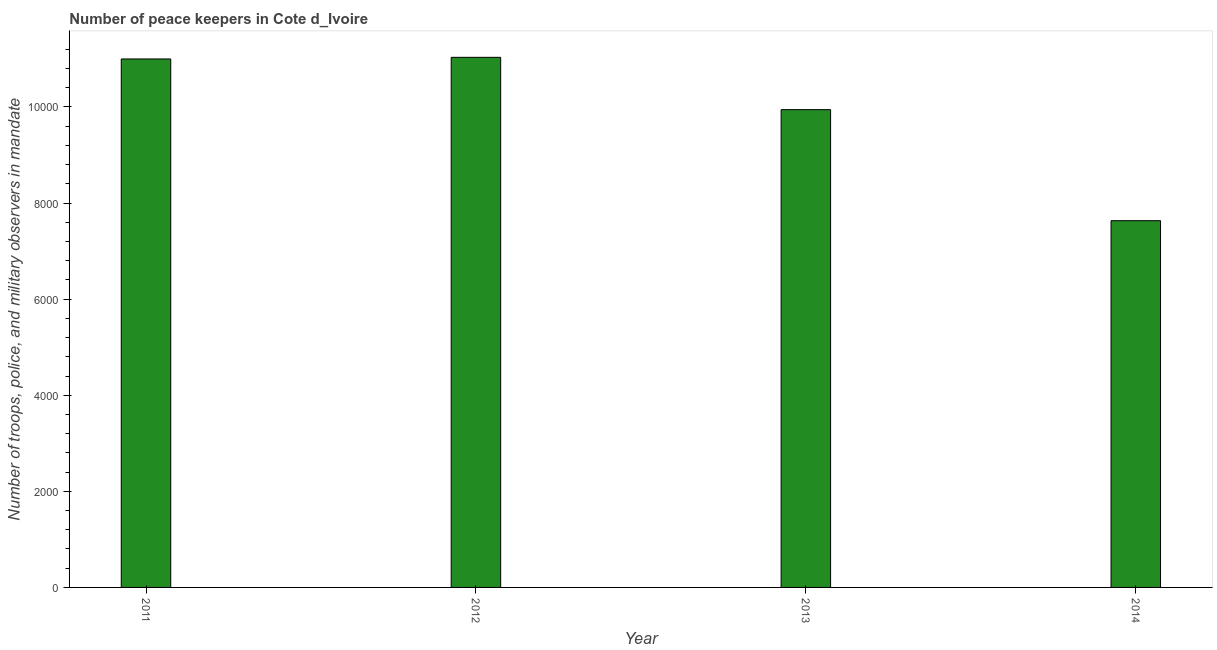Does the graph contain grids?
Provide a short and direct response. No. What is the title of the graph?
Provide a succinct answer. Number of peace keepers in Cote d_Ivoire. What is the label or title of the Y-axis?
Your answer should be very brief. Number of troops, police, and military observers in mandate. What is the number of peace keepers in 2014?
Offer a terse response. 7633. Across all years, what is the maximum number of peace keepers?
Give a very brief answer. 1.10e+04. Across all years, what is the minimum number of peace keepers?
Keep it short and to the point. 7633. In which year was the number of peace keepers minimum?
Make the answer very short. 2014. What is the sum of the number of peace keepers?
Give a very brief answer. 3.96e+04. What is the difference between the number of peace keepers in 2013 and 2014?
Provide a succinct answer. 2311. What is the average number of peace keepers per year?
Provide a succinct answer. 9902. What is the median number of peace keepers?
Keep it short and to the point. 1.05e+04. What is the ratio of the number of peace keepers in 2012 to that in 2013?
Offer a terse response. 1.11. Is the number of peace keepers in 2012 less than that in 2014?
Keep it short and to the point. No. What is the difference between the highest and the second highest number of peace keepers?
Offer a very short reply. 34. Is the sum of the number of peace keepers in 2013 and 2014 greater than the maximum number of peace keepers across all years?
Offer a terse response. Yes. What is the difference between the highest and the lowest number of peace keepers?
Your answer should be compact. 3400. In how many years, is the number of peace keepers greater than the average number of peace keepers taken over all years?
Offer a very short reply. 3. Are all the bars in the graph horizontal?
Make the answer very short. No. What is the difference between two consecutive major ticks on the Y-axis?
Make the answer very short. 2000. Are the values on the major ticks of Y-axis written in scientific E-notation?
Ensure brevity in your answer.  No. What is the Number of troops, police, and military observers in mandate in 2011?
Ensure brevity in your answer.  1.10e+04. What is the Number of troops, police, and military observers in mandate of 2012?
Your response must be concise. 1.10e+04. What is the Number of troops, police, and military observers in mandate of 2013?
Your response must be concise. 9944. What is the Number of troops, police, and military observers in mandate of 2014?
Offer a very short reply. 7633. What is the difference between the Number of troops, police, and military observers in mandate in 2011 and 2012?
Provide a succinct answer. -34. What is the difference between the Number of troops, police, and military observers in mandate in 2011 and 2013?
Your answer should be very brief. 1055. What is the difference between the Number of troops, police, and military observers in mandate in 2011 and 2014?
Provide a short and direct response. 3366. What is the difference between the Number of troops, police, and military observers in mandate in 2012 and 2013?
Your answer should be compact. 1089. What is the difference between the Number of troops, police, and military observers in mandate in 2012 and 2014?
Your response must be concise. 3400. What is the difference between the Number of troops, police, and military observers in mandate in 2013 and 2014?
Offer a very short reply. 2311. What is the ratio of the Number of troops, police, and military observers in mandate in 2011 to that in 2012?
Keep it short and to the point. 1. What is the ratio of the Number of troops, police, and military observers in mandate in 2011 to that in 2013?
Provide a short and direct response. 1.11. What is the ratio of the Number of troops, police, and military observers in mandate in 2011 to that in 2014?
Keep it short and to the point. 1.44. What is the ratio of the Number of troops, police, and military observers in mandate in 2012 to that in 2013?
Your answer should be very brief. 1.11. What is the ratio of the Number of troops, police, and military observers in mandate in 2012 to that in 2014?
Ensure brevity in your answer.  1.45. What is the ratio of the Number of troops, police, and military observers in mandate in 2013 to that in 2014?
Ensure brevity in your answer.  1.3. 